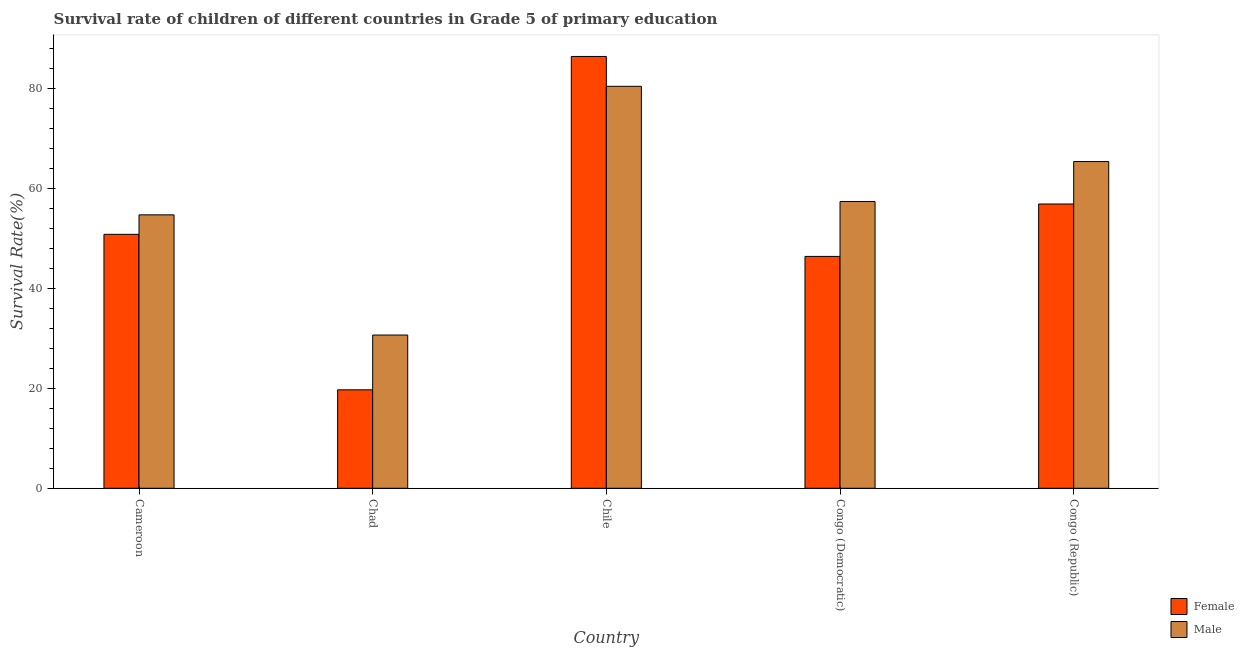How many different coloured bars are there?
Give a very brief answer. 2. Are the number of bars on each tick of the X-axis equal?
Your response must be concise. Yes. How many bars are there on the 1st tick from the right?
Make the answer very short. 2. What is the label of the 3rd group of bars from the left?
Your response must be concise. Chile. In how many cases, is the number of bars for a given country not equal to the number of legend labels?
Keep it short and to the point. 0. What is the survival rate of male students in primary education in Chile?
Keep it short and to the point. 80.45. Across all countries, what is the maximum survival rate of male students in primary education?
Provide a succinct answer. 80.45. Across all countries, what is the minimum survival rate of female students in primary education?
Offer a terse response. 19.71. In which country was the survival rate of female students in primary education minimum?
Your response must be concise. Chad. What is the total survival rate of male students in primary education in the graph?
Ensure brevity in your answer.  288.62. What is the difference between the survival rate of female students in primary education in Chile and that in Congo (Republic)?
Provide a short and direct response. 29.53. What is the difference between the survival rate of female students in primary education in Chile and the survival rate of male students in primary education in Cameroon?
Ensure brevity in your answer.  31.7. What is the average survival rate of female students in primary education per country?
Provide a short and direct response. 52.05. What is the difference between the survival rate of male students in primary education and survival rate of female students in primary education in Chile?
Provide a short and direct response. -5.97. In how many countries, is the survival rate of female students in primary education greater than 12 %?
Give a very brief answer. 5. What is the ratio of the survival rate of male students in primary education in Chad to that in Congo (Republic)?
Keep it short and to the point. 0.47. Is the survival rate of female students in primary education in Chad less than that in Congo (Republic)?
Offer a terse response. Yes. Is the difference between the survival rate of female students in primary education in Cameroon and Chile greater than the difference between the survival rate of male students in primary education in Cameroon and Chile?
Your answer should be very brief. No. What is the difference between the highest and the second highest survival rate of male students in primary education?
Provide a succinct answer. 15.06. What is the difference between the highest and the lowest survival rate of male students in primary education?
Your response must be concise. 49.78. In how many countries, is the survival rate of female students in primary education greater than the average survival rate of female students in primary education taken over all countries?
Provide a short and direct response. 2. Is the sum of the survival rate of female students in primary education in Chile and Congo (Republic) greater than the maximum survival rate of male students in primary education across all countries?
Offer a very short reply. Yes. What does the 2nd bar from the left in Cameroon represents?
Offer a very short reply. Male. What does the 1st bar from the right in Chile represents?
Offer a terse response. Male. Are all the bars in the graph horizontal?
Provide a succinct answer. No. What is the difference between two consecutive major ticks on the Y-axis?
Your answer should be very brief. 20. Are the values on the major ticks of Y-axis written in scientific E-notation?
Provide a succinct answer. No. Does the graph contain any zero values?
Your answer should be very brief. No. Does the graph contain grids?
Give a very brief answer. No. Where does the legend appear in the graph?
Keep it short and to the point. Bottom right. How many legend labels are there?
Offer a terse response. 2. What is the title of the graph?
Ensure brevity in your answer.  Survival rate of children of different countries in Grade 5 of primary education. What is the label or title of the Y-axis?
Make the answer very short. Survival Rate(%). What is the Survival Rate(%) of Female in Cameroon?
Provide a short and direct response. 50.83. What is the Survival Rate(%) in Male in Cameroon?
Provide a short and direct response. 54.72. What is the Survival Rate(%) in Female in Chad?
Your answer should be compact. 19.71. What is the Survival Rate(%) in Male in Chad?
Ensure brevity in your answer.  30.67. What is the Survival Rate(%) in Female in Chile?
Provide a short and direct response. 86.42. What is the Survival Rate(%) in Male in Chile?
Keep it short and to the point. 80.45. What is the Survival Rate(%) in Female in Congo (Democratic)?
Provide a short and direct response. 46.41. What is the Survival Rate(%) in Male in Congo (Democratic)?
Provide a succinct answer. 57.39. What is the Survival Rate(%) of Female in Congo (Republic)?
Keep it short and to the point. 56.9. What is the Survival Rate(%) in Male in Congo (Republic)?
Give a very brief answer. 65.39. Across all countries, what is the maximum Survival Rate(%) in Female?
Your response must be concise. 86.42. Across all countries, what is the maximum Survival Rate(%) in Male?
Ensure brevity in your answer.  80.45. Across all countries, what is the minimum Survival Rate(%) of Female?
Your response must be concise. 19.71. Across all countries, what is the minimum Survival Rate(%) in Male?
Offer a terse response. 30.67. What is the total Survival Rate(%) of Female in the graph?
Your answer should be compact. 260.25. What is the total Survival Rate(%) in Male in the graph?
Provide a succinct answer. 288.62. What is the difference between the Survival Rate(%) of Female in Cameroon and that in Chad?
Offer a terse response. 31.12. What is the difference between the Survival Rate(%) of Male in Cameroon and that in Chad?
Your answer should be very brief. 24.05. What is the difference between the Survival Rate(%) in Female in Cameroon and that in Chile?
Provide a succinct answer. -35.6. What is the difference between the Survival Rate(%) in Male in Cameroon and that in Chile?
Give a very brief answer. -25.73. What is the difference between the Survival Rate(%) in Female in Cameroon and that in Congo (Democratic)?
Provide a short and direct response. 4.42. What is the difference between the Survival Rate(%) of Male in Cameroon and that in Congo (Democratic)?
Your response must be concise. -2.67. What is the difference between the Survival Rate(%) of Female in Cameroon and that in Congo (Republic)?
Provide a short and direct response. -6.07. What is the difference between the Survival Rate(%) of Male in Cameroon and that in Congo (Republic)?
Your response must be concise. -10.67. What is the difference between the Survival Rate(%) of Female in Chad and that in Chile?
Offer a terse response. -66.72. What is the difference between the Survival Rate(%) of Male in Chad and that in Chile?
Your answer should be very brief. -49.78. What is the difference between the Survival Rate(%) in Female in Chad and that in Congo (Democratic)?
Keep it short and to the point. -26.7. What is the difference between the Survival Rate(%) in Male in Chad and that in Congo (Democratic)?
Provide a succinct answer. -26.72. What is the difference between the Survival Rate(%) of Female in Chad and that in Congo (Republic)?
Provide a succinct answer. -37.19. What is the difference between the Survival Rate(%) of Male in Chad and that in Congo (Republic)?
Offer a terse response. -34.72. What is the difference between the Survival Rate(%) of Female in Chile and that in Congo (Democratic)?
Offer a terse response. 40.02. What is the difference between the Survival Rate(%) in Male in Chile and that in Congo (Democratic)?
Your answer should be compact. 23.06. What is the difference between the Survival Rate(%) in Female in Chile and that in Congo (Republic)?
Give a very brief answer. 29.53. What is the difference between the Survival Rate(%) of Male in Chile and that in Congo (Republic)?
Offer a very short reply. 15.06. What is the difference between the Survival Rate(%) of Female in Congo (Democratic) and that in Congo (Republic)?
Ensure brevity in your answer.  -10.49. What is the difference between the Survival Rate(%) in Male in Congo (Democratic) and that in Congo (Republic)?
Ensure brevity in your answer.  -8. What is the difference between the Survival Rate(%) of Female in Cameroon and the Survival Rate(%) of Male in Chad?
Your response must be concise. 20.16. What is the difference between the Survival Rate(%) of Female in Cameroon and the Survival Rate(%) of Male in Chile?
Provide a succinct answer. -29.62. What is the difference between the Survival Rate(%) of Female in Cameroon and the Survival Rate(%) of Male in Congo (Democratic)?
Provide a short and direct response. -6.56. What is the difference between the Survival Rate(%) in Female in Cameroon and the Survival Rate(%) in Male in Congo (Republic)?
Make the answer very short. -14.56. What is the difference between the Survival Rate(%) in Female in Chad and the Survival Rate(%) in Male in Chile?
Offer a terse response. -60.74. What is the difference between the Survival Rate(%) in Female in Chad and the Survival Rate(%) in Male in Congo (Democratic)?
Ensure brevity in your answer.  -37.68. What is the difference between the Survival Rate(%) of Female in Chad and the Survival Rate(%) of Male in Congo (Republic)?
Provide a succinct answer. -45.68. What is the difference between the Survival Rate(%) in Female in Chile and the Survival Rate(%) in Male in Congo (Democratic)?
Keep it short and to the point. 29.03. What is the difference between the Survival Rate(%) of Female in Chile and the Survival Rate(%) of Male in Congo (Republic)?
Offer a very short reply. 21.03. What is the difference between the Survival Rate(%) in Female in Congo (Democratic) and the Survival Rate(%) in Male in Congo (Republic)?
Ensure brevity in your answer.  -18.98. What is the average Survival Rate(%) of Female per country?
Keep it short and to the point. 52.05. What is the average Survival Rate(%) in Male per country?
Give a very brief answer. 57.72. What is the difference between the Survival Rate(%) in Female and Survival Rate(%) in Male in Cameroon?
Your answer should be compact. -3.9. What is the difference between the Survival Rate(%) of Female and Survival Rate(%) of Male in Chad?
Offer a very short reply. -10.96. What is the difference between the Survival Rate(%) of Female and Survival Rate(%) of Male in Chile?
Ensure brevity in your answer.  5.97. What is the difference between the Survival Rate(%) of Female and Survival Rate(%) of Male in Congo (Democratic)?
Ensure brevity in your answer.  -10.98. What is the difference between the Survival Rate(%) of Female and Survival Rate(%) of Male in Congo (Republic)?
Offer a terse response. -8.49. What is the ratio of the Survival Rate(%) in Female in Cameroon to that in Chad?
Offer a terse response. 2.58. What is the ratio of the Survival Rate(%) in Male in Cameroon to that in Chad?
Make the answer very short. 1.78. What is the ratio of the Survival Rate(%) in Female in Cameroon to that in Chile?
Provide a short and direct response. 0.59. What is the ratio of the Survival Rate(%) of Male in Cameroon to that in Chile?
Offer a very short reply. 0.68. What is the ratio of the Survival Rate(%) of Female in Cameroon to that in Congo (Democratic)?
Provide a short and direct response. 1.1. What is the ratio of the Survival Rate(%) of Male in Cameroon to that in Congo (Democratic)?
Offer a terse response. 0.95. What is the ratio of the Survival Rate(%) of Female in Cameroon to that in Congo (Republic)?
Your answer should be very brief. 0.89. What is the ratio of the Survival Rate(%) in Male in Cameroon to that in Congo (Republic)?
Give a very brief answer. 0.84. What is the ratio of the Survival Rate(%) in Female in Chad to that in Chile?
Provide a succinct answer. 0.23. What is the ratio of the Survival Rate(%) of Male in Chad to that in Chile?
Offer a terse response. 0.38. What is the ratio of the Survival Rate(%) of Female in Chad to that in Congo (Democratic)?
Ensure brevity in your answer.  0.42. What is the ratio of the Survival Rate(%) in Male in Chad to that in Congo (Democratic)?
Keep it short and to the point. 0.53. What is the ratio of the Survival Rate(%) in Female in Chad to that in Congo (Republic)?
Your answer should be compact. 0.35. What is the ratio of the Survival Rate(%) in Male in Chad to that in Congo (Republic)?
Offer a very short reply. 0.47. What is the ratio of the Survival Rate(%) in Female in Chile to that in Congo (Democratic)?
Make the answer very short. 1.86. What is the ratio of the Survival Rate(%) of Male in Chile to that in Congo (Democratic)?
Make the answer very short. 1.4. What is the ratio of the Survival Rate(%) of Female in Chile to that in Congo (Republic)?
Provide a short and direct response. 1.52. What is the ratio of the Survival Rate(%) of Male in Chile to that in Congo (Republic)?
Your response must be concise. 1.23. What is the ratio of the Survival Rate(%) of Female in Congo (Democratic) to that in Congo (Republic)?
Make the answer very short. 0.82. What is the ratio of the Survival Rate(%) in Male in Congo (Democratic) to that in Congo (Republic)?
Your answer should be very brief. 0.88. What is the difference between the highest and the second highest Survival Rate(%) in Female?
Give a very brief answer. 29.53. What is the difference between the highest and the second highest Survival Rate(%) of Male?
Offer a very short reply. 15.06. What is the difference between the highest and the lowest Survival Rate(%) of Female?
Ensure brevity in your answer.  66.72. What is the difference between the highest and the lowest Survival Rate(%) in Male?
Your response must be concise. 49.78. 